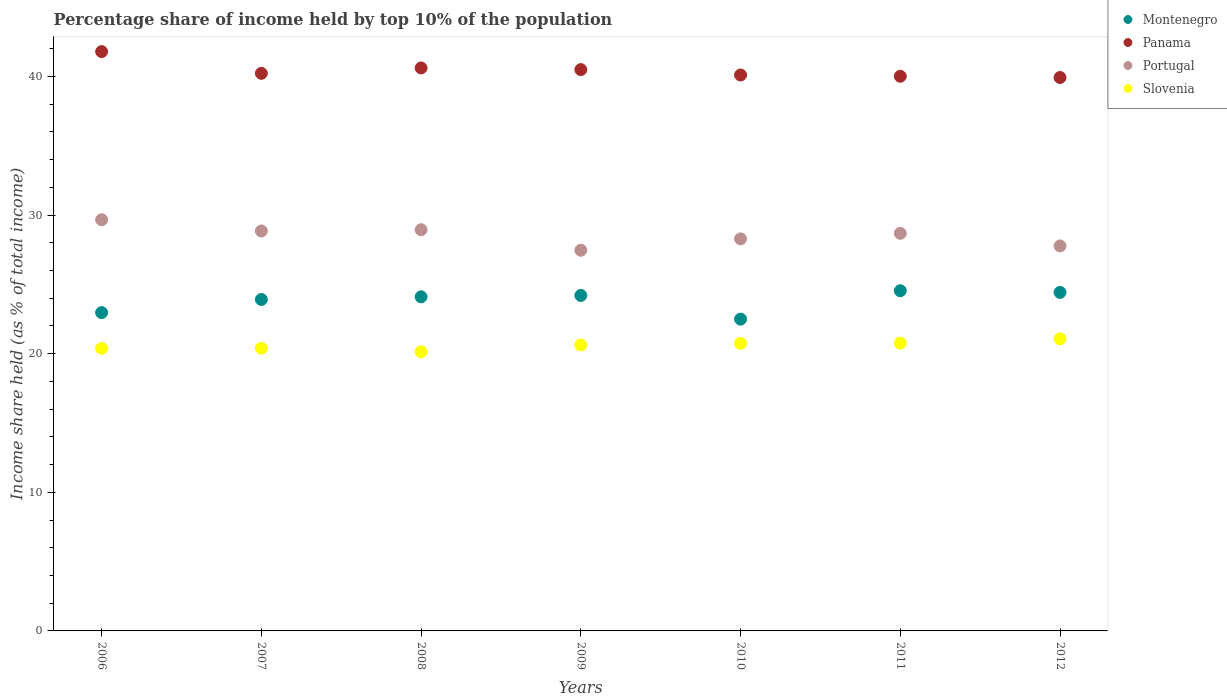Is the number of dotlines equal to the number of legend labels?
Keep it short and to the point. Yes. What is the percentage share of income held by top 10% of the population in Panama in 2009?
Your answer should be very brief. 40.49. Across all years, what is the maximum percentage share of income held by top 10% of the population in Slovenia?
Make the answer very short. 21.07. Across all years, what is the minimum percentage share of income held by top 10% of the population in Montenegro?
Offer a terse response. 22.49. What is the total percentage share of income held by top 10% of the population in Slovenia in the graph?
Your answer should be very brief. 144.11. What is the difference between the percentage share of income held by top 10% of the population in Montenegro in 2008 and that in 2010?
Keep it short and to the point. 1.61. What is the difference between the percentage share of income held by top 10% of the population in Portugal in 2006 and the percentage share of income held by top 10% of the population in Panama in 2007?
Provide a succinct answer. -10.56. What is the average percentage share of income held by top 10% of the population in Portugal per year?
Provide a short and direct response. 28.52. In the year 2006, what is the difference between the percentage share of income held by top 10% of the population in Slovenia and percentage share of income held by top 10% of the population in Montenegro?
Give a very brief answer. -2.58. In how many years, is the percentage share of income held by top 10% of the population in Portugal greater than 36 %?
Give a very brief answer. 0. What is the ratio of the percentage share of income held by top 10% of the population in Montenegro in 2006 to that in 2011?
Give a very brief answer. 0.94. What is the difference between the highest and the second highest percentage share of income held by top 10% of the population in Montenegro?
Your answer should be compact. 0.12. What is the difference between the highest and the lowest percentage share of income held by top 10% of the population in Panama?
Keep it short and to the point. 1.87. Is the sum of the percentage share of income held by top 10% of the population in Portugal in 2009 and 2012 greater than the maximum percentage share of income held by top 10% of the population in Montenegro across all years?
Keep it short and to the point. Yes. Is it the case that in every year, the sum of the percentage share of income held by top 10% of the population in Portugal and percentage share of income held by top 10% of the population in Montenegro  is greater than the percentage share of income held by top 10% of the population in Panama?
Provide a succinct answer. Yes. Is the percentage share of income held by top 10% of the population in Slovenia strictly greater than the percentage share of income held by top 10% of the population in Portugal over the years?
Offer a very short reply. No. Is the percentage share of income held by top 10% of the population in Portugal strictly less than the percentage share of income held by top 10% of the population in Slovenia over the years?
Offer a terse response. No. How many dotlines are there?
Provide a short and direct response. 4. How many years are there in the graph?
Give a very brief answer. 7. What is the difference between two consecutive major ticks on the Y-axis?
Provide a succinct answer. 10. Are the values on the major ticks of Y-axis written in scientific E-notation?
Your response must be concise. No. Where does the legend appear in the graph?
Offer a terse response. Top right. How many legend labels are there?
Offer a terse response. 4. What is the title of the graph?
Keep it short and to the point. Percentage share of income held by top 10% of the population. What is the label or title of the Y-axis?
Your answer should be compact. Income share held (as % of total income). What is the Income share held (as % of total income) of Montenegro in 2006?
Provide a succinct answer. 22.96. What is the Income share held (as % of total income) of Panama in 2006?
Keep it short and to the point. 41.79. What is the Income share held (as % of total income) in Portugal in 2006?
Your answer should be compact. 29.66. What is the Income share held (as % of total income) in Slovenia in 2006?
Provide a succinct answer. 20.38. What is the Income share held (as % of total income) of Montenegro in 2007?
Provide a succinct answer. 23.91. What is the Income share held (as % of total income) in Panama in 2007?
Your response must be concise. 40.22. What is the Income share held (as % of total income) of Portugal in 2007?
Keep it short and to the point. 28.85. What is the Income share held (as % of total income) of Slovenia in 2007?
Provide a short and direct response. 20.39. What is the Income share held (as % of total income) of Montenegro in 2008?
Make the answer very short. 24.1. What is the Income share held (as % of total income) of Panama in 2008?
Your answer should be very brief. 40.61. What is the Income share held (as % of total income) in Portugal in 2008?
Ensure brevity in your answer.  28.94. What is the Income share held (as % of total income) in Slovenia in 2008?
Ensure brevity in your answer.  20.14. What is the Income share held (as % of total income) in Montenegro in 2009?
Offer a terse response. 24.2. What is the Income share held (as % of total income) of Panama in 2009?
Ensure brevity in your answer.  40.49. What is the Income share held (as % of total income) in Portugal in 2009?
Your response must be concise. 27.46. What is the Income share held (as % of total income) in Slovenia in 2009?
Provide a short and direct response. 20.63. What is the Income share held (as % of total income) of Montenegro in 2010?
Offer a very short reply. 22.49. What is the Income share held (as % of total income) in Panama in 2010?
Offer a very short reply. 40.1. What is the Income share held (as % of total income) in Portugal in 2010?
Provide a succinct answer. 28.28. What is the Income share held (as % of total income) of Slovenia in 2010?
Your response must be concise. 20.74. What is the Income share held (as % of total income) of Montenegro in 2011?
Keep it short and to the point. 24.54. What is the Income share held (as % of total income) of Panama in 2011?
Provide a short and direct response. 40.01. What is the Income share held (as % of total income) in Portugal in 2011?
Offer a terse response. 28.68. What is the Income share held (as % of total income) in Slovenia in 2011?
Offer a very short reply. 20.76. What is the Income share held (as % of total income) in Montenegro in 2012?
Provide a short and direct response. 24.42. What is the Income share held (as % of total income) of Panama in 2012?
Give a very brief answer. 39.92. What is the Income share held (as % of total income) in Portugal in 2012?
Your answer should be compact. 27.77. What is the Income share held (as % of total income) of Slovenia in 2012?
Give a very brief answer. 21.07. Across all years, what is the maximum Income share held (as % of total income) of Montenegro?
Give a very brief answer. 24.54. Across all years, what is the maximum Income share held (as % of total income) of Panama?
Offer a terse response. 41.79. Across all years, what is the maximum Income share held (as % of total income) of Portugal?
Make the answer very short. 29.66. Across all years, what is the maximum Income share held (as % of total income) of Slovenia?
Offer a very short reply. 21.07. Across all years, what is the minimum Income share held (as % of total income) in Montenegro?
Your answer should be compact. 22.49. Across all years, what is the minimum Income share held (as % of total income) of Panama?
Provide a short and direct response. 39.92. Across all years, what is the minimum Income share held (as % of total income) in Portugal?
Keep it short and to the point. 27.46. Across all years, what is the minimum Income share held (as % of total income) of Slovenia?
Give a very brief answer. 20.14. What is the total Income share held (as % of total income) in Montenegro in the graph?
Keep it short and to the point. 166.62. What is the total Income share held (as % of total income) of Panama in the graph?
Provide a short and direct response. 283.14. What is the total Income share held (as % of total income) in Portugal in the graph?
Your response must be concise. 199.64. What is the total Income share held (as % of total income) in Slovenia in the graph?
Ensure brevity in your answer.  144.11. What is the difference between the Income share held (as % of total income) of Montenegro in 2006 and that in 2007?
Provide a short and direct response. -0.95. What is the difference between the Income share held (as % of total income) in Panama in 2006 and that in 2007?
Make the answer very short. 1.57. What is the difference between the Income share held (as % of total income) in Portugal in 2006 and that in 2007?
Your answer should be very brief. 0.81. What is the difference between the Income share held (as % of total income) in Slovenia in 2006 and that in 2007?
Keep it short and to the point. -0.01. What is the difference between the Income share held (as % of total income) in Montenegro in 2006 and that in 2008?
Give a very brief answer. -1.14. What is the difference between the Income share held (as % of total income) in Panama in 2006 and that in 2008?
Your answer should be very brief. 1.18. What is the difference between the Income share held (as % of total income) of Portugal in 2006 and that in 2008?
Give a very brief answer. 0.72. What is the difference between the Income share held (as % of total income) in Slovenia in 2006 and that in 2008?
Offer a terse response. 0.24. What is the difference between the Income share held (as % of total income) in Montenegro in 2006 and that in 2009?
Offer a terse response. -1.24. What is the difference between the Income share held (as % of total income) in Slovenia in 2006 and that in 2009?
Provide a short and direct response. -0.25. What is the difference between the Income share held (as % of total income) of Montenegro in 2006 and that in 2010?
Your answer should be compact. 0.47. What is the difference between the Income share held (as % of total income) in Panama in 2006 and that in 2010?
Your answer should be compact. 1.69. What is the difference between the Income share held (as % of total income) in Portugal in 2006 and that in 2010?
Provide a succinct answer. 1.38. What is the difference between the Income share held (as % of total income) in Slovenia in 2006 and that in 2010?
Your answer should be very brief. -0.36. What is the difference between the Income share held (as % of total income) of Montenegro in 2006 and that in 2011?
Make the answer very short. -1.58. What is the difference between the Income share held (as % of total income) of Panama in 2006 and that in 2011?
Give a very brief answer. 1.78. What is the difference between the Income share held (as % of total income) in Portugal in 2006 and that in 2011?
Your answer should be compact. 0.98. What is the difference between the Income share held (as % of total income) in Slovenia in 2006 and that in 2011?
Keep it short and to the point. -0.38. What is the difference between the Income share held (as % of total income) of Montenegro in 2006 and that in 2012?
Your response must be concise. -1.46. What is the difference between the Income share held (as % of total income) of Panama in 2006 and that in 2012?
Keep it short and to the point. 1.87. What is the difference between the Income share held (as % of total income) in Portugal in 2006 and that in 2012?
Your response must be concise. 1.89. What is the difference between the Income share held (as % of total income) of Slovenia in 2006 and that in 2012?
Offer a terse response. -0.69. What is the difference between the Income share held (as % of total income) in Montenegro in 2007 and that in 2008?
Offer a very short reply. -0.19. What is the difference between the Income share held (as % of total income) in Panama in 2007 and that in 2008?
Your answer should be very brief. -0.39. What is the difference between the Income share held (as % of total income) of Portugal in 2007 and that in 2008?
Ensure brevity in your answer.  -0.09. What is the difference between the Income share held (as % of total income) in Montenegro in 2007 and that in 2009?
Keep it short and to the point. -0.29. What is the difference between the Income share held (as % of total income) in Panama in 2007 and that in 2009?
Your answer should be compact. -0.27. What is the difference between the Income share held (as % of total income) in Portugal in 2007 and that in 2009?
Your answer should be compact. 1.39. What is the difference between the Income share held (as % of total income) of Slovenia in 2007 and that in 2009?
Provide a succinct answer. -0.24. What is the difference between the Income share held (as % of total income) in Montenegro in 2007 and that in 2010?
Offer a terse response. 1.42. What is the difference between the Income share held (as % of total income) in Panama in 2007 and that in 2010?
Provide a short and direct response. 0.12. What is the difference between the Income share held (as % of total income) of Portugal in 2007 and that in 2010?
Make the answer very short. 0.57. What is the difference between the Income share held (as % of total income) in Slovenia in 2007 and that in 2010?
Your answer should be compact. -0.35. What is the difference between the Income share held (as % of total income) of Montenegro in 2007 and that in 2011?
Give a very brief answer. -0.63. What is the difference between the Income share held (as % of total income) in Panama in 2007 and that in 2011?
Ensure brevity in your answer.  0.21. What is the difference between the Income share held (as % of total income) in Portugal in 2007 and that in 2011?
Ensure brevity in your answer.  0.17. What is the difference between the Income share held (as % of total income) of Slovenia in 2007 and that in 2011?
Make the answer very short. -0.37. What is the difference between the Income share held (as % of total income) in Montenegro in 2007 and that in 2012?
Provide a short and direct response. -0.51. What is the difference between the Income share held (as % of total income) of Panama in 2007 and that in 2012?
Keep it short and to the point. 0.3. What is the difference between the Income share held (as % of total income) of Portugal in 2007 and that in 2012?
Your answer should be very brief. 1.08. What is the difference between the Income share held (as % of total income) in Slovenia in 2007 and that in 2012?
Your response must be concise. -0.68. What is the difference between the Income share held (as % of total income) in Montenegro in 2008 and that in 2009?
Your answer should be compact. -0.1. What is the difference between the Income share held (as % of total income) in Panama in 2008 and that in 2009?
Your answer should be very brief. 0.12. What is the difference between the Income share held (as % of total income) of Portugal in 2008 and that in 2009?
Provide a succinct answer. 1.48. What is the difference between the Income share held (as % of total income) in Slovenia in 2008 and that in 2009?
Ensure brevity in your answer.  -0.49. What is the difference between the Income share held (as % of total income) in Montenegro in 2008 and that in 2010?
Your answer should be compact. 1.61. What is the difference between the Income share held (as % of total income) in Panama in 2008 and that in 2010?
Provide a short and direct response. 0.51. What is the difference between the Income share held (as % of total income) in Portugal in 2008 and that in 2010?
Offer a terse response. 0.66. What is the difference between the Income share held (as % of total income) in Montenegro in 2008 and that in 2011?
Your answer should be very brief. -0.44. What is the difference between the Income share held (as % of total income) in Portugal in 2008 and that in 2011?
Ensure brevity in your answer.  0.26. What is the difference between the Income share held (as % of total income) in Slovenia in 2008 and that in 2011?
Provide a short and direct response. -0.62. What is the difference between the Income share held (as % of total income) of Montenegro in 2008 and that in 2012?
Your answer should be compact. -0.32. What is the difference between the Income share held (as % of total income) of Panama in 2008 and that in 2012?
Ensure brevity in your answer.  0.69. What is the difference between the Income share held (as % of total income) of Portugal in 2008 and that in 2012?
Give a very brief answer. 1.17. What is the difference between the Income share held (as % of total income) of Slovenia in 2008 and that in 2012?
Your response must be concise. -0.93. What is the difference between the Income share held (as % of total income) in Montenegro in 2009 and that in 2010?
Provide a short and direct response. 1.71. What is the difference between the Income share held (as % of total income) of Panama in 2009 and that in 2010?
Your answer should be compact. 0.39. What is the difference between the Income share held (as % of total income) of Portugal in 2009 and that in 2010?
Provide a succinct answer. -0.82. What is the difference between the Income share held (as % of total income) of Slovenia in 2009 and that in 2010?
Ensure brevity in your answer.  -0.11. What is the difference between the Income share held (as % of total income) of Montenegro in 2009 and that in 2011?
Your response must be concise. -0.34. What is the difference between the Income share held (as % of total income) in Panama in 2009 and that in 2011?
Ensure brevity in your answer.  0.48. What is the difference between the Income share held (as % of total income) in Portugal in 2009 and that in 2011?
Give a very brief answer. -1.22. What is the difference between the Income share held (as % of total income) of Slovenia in 2009 and that in 2011?
Your response must be concise. -0.13. What is the difference between the Income share held (as % of total income) of Montenegro in 2009 and that in 2012?
Offer a terse response. -0.22. What is the difference between the Income share held (as % of total income) of Panama in 2009 and that in 2012?
Keep it short and to the point. 0.57. What is the difference between the Income share held (as % of total income) of Portugal in 2009 and that in 2012?
Give a very brief answer. -0.31. What is the difference between the Income share held (as % of total income) of Slovenia in 2009 and that in 2012?
Your response must be concise. -0.44. What is the difference between the Income share held (as % of total income) of Montenegro in 2010 and that in 2011?
Your answer should be compact. -2.05. What is the difference between the Income share held (as % of total income) of Panama in 2010 and that in 2011?
Give a very brief answer. 0.09. What is the difference between the Income share held (as % of total income) of Portugal in 2010 and that in 2011?
Your answer should be very brief. -0.4. What is the difference between the Income share held (as % of total income) of Slovenia in 2010 and that in 2011?
Provide a succinct answer. -0.02. What is the difference between the Income share held (as % of total income) in Montenegro in 2010 and that in 2012?
Your response must be concise. -1.93. What is the difference between the Income share held (as % of total income) of Panama in 2010 and that in 2012?
Provide a short and direct response. 0.18. What is the difference between the Income share held (as % of total income) of Portugal in 2010 and that in 2012?
Provide a succinct answer. 0.51. What is the difference between the Income share held (as % of total income) in Slovenia in 2010 and that in 2012?
Offer a terse response. -0.33. What is the difference between the Income share held (as % of total income) in Montenegro in 2011 and that in 2012?
Keep it short and to the point. 0.12. What is the difference between the Income share held (as % of total income) in Panama in 2011 and that in 2012?
Ensure brevity in your answer.  0.09. What is the difference between the Income share held (as % of total income) of Portugal in 2011 and that in 2012?
Offer a very short reply. 0.91. What is the difference between the Income share held (as % of total income) in Slovenia in 2011 and that in 2012?
Offer a very short reply. -0.31. What is the difference between the Income share held (as % of total income) in Montenegro in 2006 and the Income share held (as % of total income) in Panama in 2007?
Make the answer very short. -17.26. What is the difference between the Income share held (as % of total income) in Montenegro in 2006 and the Income share held (as % of total income) in Portugal in 2007?
Offer a terse response. -5.89. What is the difference between the Income share held (as % of total income) of Montenegro in 2006 and the Income share held (as % of total income) of Slovenia in 2007?
Your answer should be very brief. 2.57. What is the difference between the Income share held (as % of total income) in Panama in 2006 and the Income share held (as % of total income) in Portugal in 2007?
Provide a succinct answer. 12.94. What is the difference between the Income share held (as % of total income) of Panama in 2006 and the Income share held (as % of total income) of Slovenia in 2007?
Make the answer very short. 21.4. What is the difference between the Income share held (as % of total income) of Portugal in 2006 and the Income share held (as % of total income) of Slovenia in 2007?
Your response must be concise. 9.27. What is the difference between the Income share held (as % of total income) of Montenegro in 2006 and the Income share held (as % of total income) of Panama in 2008?
Provide a succinct answer. -17.65. What is the difference between the Income share held (as % of total income) in Montenegro in 2006 and the Income share held (as % of total income) in Portugal in 2008?
Ensure brevity in your answer.  -5.98. What is the difference between the Income share held (as % of total income) in Montenegro in 2006 and the Income share held (as % of total income) in Slovenia in 2008?
Your answer should be compact. 2.82. What is the difference between the Income share held (as % of total income) of Panama in 2006 and the Income share held (as % of total income) of Portugal in 2008?
Provide a succinct answer. 12.85. What is the difference between the Income share held (as % of total income) of Panama in 2006 and the Income share held (as % of total income) of Slovenia in 2008?
Your answer should be compact. 21.65. What is the difference between the Income share held (as % of total income) in Portugal in 2006 and the Income share held (as % of total income) in Slovenia in 2008?
Provide a succinct answer. 9.52. What is the difference between the Income share held (as % of total income) in Montenegro in 2006 and the Income share held (as % of total income) in Panama in 2009?
Keep it short and to the point. -17.53. What is the difference between the Income share held (as % of total income) in Montenegro in 2006 and the Income share held (as % of total income) in Portugal in 2009?
Provide a succinct answer. -4.5. What is the difference between the Income share held (as % of total income) of Montenegro in 2006 and the Income share held (as % of total income) of Slovenia in 2009?
Provide a short and direct response. 2.33. What is the difference between the Income share held (as % of total income) of Panama in 2006 and the Income share held (as % of total income) of Portugal in 2009?
Give a very brief answer. 14.33. What is the difference between the Income share held (as % of total income) of Panama in 2006 and the Income share held (as % of total income) of Slovenia in 2009?
Your answer should be very brief. 21.16. What is the difference between the Income share held (as % of total income) of Portugal in 2006 and the Income share held (as % of total income) of Slovenia in 2009?
Your answer should be compact. 9.03. What is the difference between the Income share held (as % of total income) of Montenegro in 2006 and the Income share held (as % of total income) of Panama in 2010?
Offer a terse response. -17.14. What is the difference between the Income share held (as % of total income) in Montenegro in 2006 and the Income share held (as % of total income) in Portugal in 2010?
Give a very brief answer. -5.32. What is the difference between the Income share held (as % of total income) in Montenegro in 2006 and the Income share held (as % of total income) in Slovenia in 2010?
Provide a short and direct response. 2.22. What is the difference between the Income share held (as % of total income) of Panama in 2006 and the Income share held (as % of total income) of Portugal in 2010?
Provide a short and direct response. 13.51. What is the difference between the Income share held (as % of total income) of Panama in 2006 and the Income share held (as % of total income) of Slovenia in 2010?
Keep it short and to the point. 21.05. What is the difference between the Income share held (as % of total income) in Portugal in 2006 and the Income share held (as % of total income) in Slovenia in 2010?
Keep it short and to the point. 8.92. What is the difference between the Income share held (as % of total income) in Montenegro in 2006 and the Income share held (as % of total income) in Panama in 2011?
Your response must be concise. -17.05. What is the difference between the Income share held (as % of total income) in Montenegro in 2006 and the Income share held (as % of total income) in Portugal in 2011?
Provide a short and direct response. -5.72. What is the difference between the Income share held (as % of total income) of Panama in 2006 and the Income share held (as % of total income) of Portugal in 2011?
Ensure brevity in your answer.  13.11. What is the difference between the Income share held (as % of total income) in Panama in 2006 and the Income share held (as % of total income) in Slovenia in 2011?
Offer a terse response. 21.03. What is the difference between the Income share held (as % of total income) of Montenegro in 2006 and the Income share held (as % of total income) of Panama in 2012?
Offer a terse response. -16.96. What is the difference between the Income share held (as % of total income) in Montenegro in 2006 and the Income share held (as % of total income) in Portugal in 2012?
Ensure brevity in your answer.  -4.81. What is the difference between the Income share held (as % of total income) of Montenegro in 2006 and the Income share held (as % of total income) of Slovenia in 2012?
Provide a succinct answer. 1.89. What is the difference between the Income share held (as % of total income) in Panama in 2006 and the Income share held (as % of total income) in Portugal in 2012?
Your answer should be very brief. 14.02. What is the difference between the Income share held (as % of total income) in Panama in 2006 and the Income share held (as % of total income) in Slovenia in 2012?
Provide a succinct answer. 20.72. What is the difference between the Income share held (as % of total income) in Portugal in 2006 and the Income share held (as % of total income) in Slovenia in 2012?
Keep it short and to the point. 8.59. What is the difference between the Income share held (as % of total income) in Montenegro in 2007 and the Income share held (as % of total income) in Panama in 2008?
Provide a short and direct response. -16.7. What is the difference between the Income share held (as % of total income) in Montenegro in 2007 and the Income share held (as % of total income) in Portugal in 2008?
Your response must be concise. -5.03. What is the difference between the Income share held (as % of total income) in Montenegro in 2007 and the Income share held (as % of total income) in Slovenia in 2008?
Your answer should be very brief. 3.77. What is the difference between the Income share held (as % of total income) of Panama in 2007 and the Income share held (as % of total income) of Portugal in 2008?
Provide a succinct answer. 11.28. What is the difference between the Income share held (as % of total income) in Panama in 2007 and the Income share held (as % of total income) in Slovenia in 2008?
Offer a very short reply. 20.08. What is the difference between the Income share held (as % of total income) of Portugal in 2007 and the Income share held (as % of total income) of Slovenia in 2008?
Give a very brief answer. 8.71. What is the difference between the Income share held (as % of total income) in Montenegro in 2007 and the Income share held (as % of total income) in Panama in 2009?
Ensure brevity in your answer.  -16.58. What is the difference between the Income share held (as % of total income) in Montenegro in 2007 and the Income share held (as % of total income) in Portugal in 2009?
Provide a short and direct response. -3.55. What is the difference between the Income share held (as % of total income) in Montenegro in 2007 and the Income share held (as % of total income) in Slovenia in 2009?
Your response must be concise. 3.28. What is the difference between the Income share held (as % of total income) of Panama in 2007 and the Income share held (as % of total income) of Portugal in 2009?
Provide a succinct answer. 12.76. What is the difference between the Income share held (as % of total income) of Panama in 2007 and the Income share held (as % of total income) of Slovenia in 2009?
Your response must be concise. 19.59. What is the difference between the Income share held (as % of total income) of Portugal in 2007 and the Income share held (as % of total income) of Slovenia in 2009?
Provide a succinct answer. 8.22. What is the difference between the Income share held (as % of total income) in Montenegro in 2007 and the Income share held (as % of total income) in Panama in 2010?
Your answer should be very brief. -16.19. What is the difference between the Income share held (as % of total income) of Montenegro in 2007 and the Income share held (as % of total income) of Portugal in 2010?
Your answer should be very brief. -4.37. What is the difference between the Income share held (as % of total income) of Montenegro in 2007 and the Income share held (as % of total income) of Slovenia in 2010?
Offer a very short reply. 3.17. What is the difference between the Income share held (as % of total income) in Panama in 2007 and the Income share held (as % of total income) in Portugal in 2010?
Provide a succinct answer. 11.94. What is the difference between the Income share held (as % of total income) of Panama in 2007 and the Income share held (as % of total income) of Slovenia in 2010?
Your answer should be very brief. 19.48. What is the difference between the Income share held (as % of total income) in Portugal in 2007 and the Income share held (as % of total income) in Slovenia in 2010?
Offer a very short reply. 8.11. What is the difference between the Income share held (as % of total income) in Montenegro in 2007 and the Income share held (as % of total income) in Panama in 2011?
Ensure brevity in your answer.  -16.1. What is the difference between the Income share held (as % of total income) of Montenegro in 2007 and the Income share held (as % of total income) of Portugal in 2011?
Ensure brevity in your answer.  -4.77. What is the difference between the Income share held (as % of total income) in Montenegro in 2007 and the Income share held (as % of total income) in Slovenia in 2011?
Your answer should be compact. 3.15. What is the difference between the Income share held (as % of total income) in Panama in 2007 and the Income share held (as % of total income) in Portugal in 2011?
Provide a succinct answer. 11.54. What is the difference between the Income share held (as % of total income) of Panama in 2007 and the Income share held (as % of total income) of Slovenia in 2011?
Offer a terse response. 19.46. What is the difference between the Income share held (as % of total income) of Portugal in 2007 and the Income share held (as % of total income) of Slovenia in 2011?
Give a very brief answer. 8.09. What is the difference between the Income share held (as % of total income) of Montenegro in 2007 and the Income share held (as % of total income) of Panama in 2012?
Your answer should be very brief. -16.01. What is the difference between the Income share held (as % of total income) of Montenegro in 2007 and the Income share held (as % of total income) of Portugal in 2012?
Ensure brevity in your answer.  -3.86. What is the difference between the Income share held (as % of total income) in Montenegro in 2007 and the Income share held (as % of total income) in Slovenia in 2012?
Give a very brief answer. 2.84. What is the difference between the Income share held (as % of total income) in Panama in 2007 and the Income share held (as % of total income) in Portugal in 2012?
Offer a very short reply. 12.45. What is the difference between the Income share held (as % of total income) in Panama in 2007 and the Income share held (as % of total income) in Slovenia in 2012?
Provide a short and direct response. 19.15. What is the difference between the Income share held (as % of total income) of Portugal in 2007 and the Income share held (as % of total income) of Slovenia in 2012?
Keep it short and to the point. 7.78. What is the difference between the Income share held (as % of total income) in Montenegro in 2008 and the Income share held (as % of total income) in Panama in 2009?
Offer a very short reply. -16.39. What is the difference between the Income share held (as % of total income) in Montenegro in 2008 and the Income share held (as % of total income) in Portugal in 2009?
Provide a short and direct response. -3.36. What is the difference between the Income share held (as % of total income) of Montenegro in 2008 and the Income share held (as % of total income) of Slovenia in 2009?
Your answer should be compact. 3.47. What is the difference between the Income share held (as % of total income) of Panama in 2008 and the Income share held (as % of total income) of Portugal in 2009?
Offer a very short reply. 13.15. What is the difference between the Income share held (as % of total income) of Panama in 2008 and the Income share held (as % of total income) of Slovenia in 2009?
Provide a short and direct response. 19.98. What is the difference between the Income share held (as % of total income) in Portugal in 2008 and the Income share held (as % of total income) in Slovenia in 2009?
Provide a short and direct response. 8.31. What is the difference between the Income share held (as % of total income) of Montenegro in 2008 and the Income share held (as % of total income) of Panama in 2010?
Provide a succinct answer. -16. What is the difference between the Income share held (as % of total income) of Montenegro in 2008 and the Income share held (as % of total income) of Portugal in 2010?
Keep it short and to the point. -4.18. What is the difference between the Income share held (as % of total income) in Montenegro in 2008 and the Income share held (as % of total income) in Slovenia in 2010?
Offer a terse response. 3.36. What is the difference between the Income share held (as % of total income) in Panama in 2008 and the Income share held (as % of total income) in Portugal in 2010?
Ensure brevity in your answer.  12.33. What is the difference between the Income share held (as % of total income) of Panama in 2008 and the Income share held (as % of total income) of Slovenia in 2010?
Make the answer very short. 19.87. What is the difference between the Income share held (as % of total income) of Portugal in 2008 and the Income share held (as % of total income) of Slovenia in 2010?
Provide a short and direct response. 8.2. What is the difference between the Income share held (as % of total income) of Montenegro in 2008 and the Income share held (as % of total income) of Panama in 2011?
Keep it short and to the point. -15.91. What is the difference between the Income share held (as % of total income) of Montenegro in 2008 and the Income share held (as % of total income) of Portugal in 2011?
Your answer should be compact. -4.58. What is the difference between the Income share held (as % of total income) of Montenegro in 2008 and the Income share held (as % of total income) of Slovenia in 2011?
Provide a short and direct response. 3.34. What is the difference between the Income share held (as % of total income) of Panama in 2008 and the Income share held (as % of total income) of Portugal in 2011?
Keep it short and to the point. 11.93. What is the difference between the Income share held (as % of total income) in Panama in 2008 and the Income share held (as % of total income) in Slovenia in 2011?
Your response must be concise. 19.85. What is the difference between the Income share held (as % of total income) of Portugal in 2008 and the Income share held (as % of total income) of Slovenia in 2011?
Keep it short and to the point. 8.18. What is the difference between the Income share held (as % of total income) in Montenegro in 2008 and the Income share held (as % of total income) in Panama in 2012?
Your answer should be compact. -15.82. What is the difference between the Income share held (as % of total income) of Montenegro in 2008 and the Income share held (as % of total income) of Portugal in 2012?
Your answer should be very brief. -3.67. What is the difference between the Income share held (as % of total income) of Montenegro in 2008 and the Income share held (as % of total income) of Slovenia in 2012?
Your response must be concise. 3.03. What is the difference between the Income share held (as % of total income) of Panama in 2008 and the Income share held (as % of total income) of Portugal in 2012?
Your answer should be compact. 12.84. What is the difference between the Income share held (as % of total income) in Panama in 2008 and the Income share held (as % of total income) in Slovenia in 2012?
Your response must be concise. 19.54. What is the difference between the Income share held (as % of total income) in Portugal in 2008 and the Income share held (as % of total income) in Slovenia in 2012?
Offer a terse response. 7.87. What is the difference between the Income share held (as % of total income) of Montenegro in 2009 and the Income share held (as % of total income) of Panama in 2010?
Make the answer very short. -15.9. What is the difference between the Income share held (as % of total income) in Montenegro in 2009 and the Income share held (as % of total income) in Portugal in 2010?
Your answer should be compact. -4.08. What is the difference between the Income share held (as % of total income) in Montenegro in 2009 and the Income share held (as % of total income) in Slovenia in 2010?
Offer a very short reply. 3.46. What is the difference between the Income share held (as % of total income) of Panama in 2009 and the Income share held (as % of total income) of Portugal in 2010?
Make the answer very short. 12.21. What is the difference between the Income share held (as % of total income) of Panama in 2009 and the Income share held (as % of total income) of Slovenia in 2010?
Offer a terse response. 19.75. What is the difference between the Income share held (as % of total income) in Portugal in 2009 and the Income share held (as % of total income) in Slovenia in 2010?
Give a very brief answer. 6.72. What is the difference between the Income share held (as % of total income) in Montenegro in 2009 and the Income share held (as % of total income) in Panama in 2011?
Your answer should be very brief. -15.81. What is the difference between the Income share held (as % of total income) of Montenegro in 2009 and the Income share held (as % of total income) of Portugal in 2011?
Make the answer very short. -4.48. What is the difference between the Income share held (as % of total income) of Montenegro in 2009 and the Income share held (as % of total income) of Slovenia in 2011?
Ensure brevity in your answer.  3.44. What is the difference between the Income share held (as % of total income) in Panama in 2009 and the Income share held (as % of total income) in Portugal in 2011?
Offer a very short reply. 11.81. What is the difference between the Income share held (as % of total income) in Panama in 2009 and the Income share held (as % of total income) in Slovenia in 2011?
Keep it short and to the point. 19.73. What is the difference between the Income share held (as % of total income) in Portugal in 2009 and the Income share held (as % of total income) in Slovenia in 2011?
Your answer should be very brief. 6.7. What is the difference between the Income share held (as % of total income) of Montenegro in 2009 and the Income share held (as % of total income) of Panama in 2012?
Ensure brevity in your answer.  -15.72. What is the difference between the Income share held (as % of total income) of Montenegro in 2009 and the Income share held (as % of total income) of Portugal in 2012?
Make the answer very short. -3.57. What is the difference between the Income share held (as % of total income) of Montenegro in 2009 and the Income share held (as % of total income) of Slovenia in 2012?
Give a very brief answer. 3.13. What is the difference between the Income share held (as % of total income) in Panama in 2009 and the Income share held (as % of total income) in Portugal in 2012?
Provide a succinct answer. 12.72. What is the difference between the Income share held (as % of total income) in Panama in 2009 and the Income share held (as % of total income) in Slovenia in 2012?
Keep it short and to the point. 19.42. What is the difference between the Income share held (as % of total income) of Portugal in 2009 and the Income share held (as % of total income) of Slovenia in 2012?
Offer a terse response. 6.39. What is the difference between the Income share held (as % of total income) in Montenegro in 2010 and the Income share held (as % of total income) in Panama in 2011?
Give a very brief answer. -17.52. What is the difference between the Income share held (as % of total income) of Montenegro in 2010 and the Income share held (as % of total income) of Portugal in 2011?
Provide a short and direct response. -6.19. What is the difference between the Income share held (as % of total income) in Montenegro in 2010 and the Income share held (as % of total income) in Slovenia in 2011?
Give a very brief answer. 1.73. What is the difference between the Income share held (as % of total income) in Panama in 2010 and the Income share held (as % of total income) in Portugal in 2011?
Give a very brief answer. 11.42. What is the difference between the Income share held (as % of total income) in Panama in 2010 and the Income share held (as % of total income) in Slovenia in 2011?
Your answer should be very brief. 19.34. What is the difference between the Income share held (as % of total income) in Portugal in 2010 and the Income share held (as % of total income) in Slovenia in 2011?
Offer a terse response. 7.52. What is the difference between the Income share held (as % of total income) of Montenegro in 2010 and the Income share held (as % of total income) of Panama in 2012?
Provide a short and direct response. -17.43. What is the difference between the Income share held (as % of total income) in Montenegro in 2010 and the Income share held (as % of total income) in Portugal in 2012?
Make the answer very short. -5.28. What is the difference between the Income share held (as % of total income) of Montenegro in 2010 and the Income share held (as % of total income) of Slovenia in 2012?
Offer a very short reply. 1.42. What is the difference between the Income share held (as % of total income) of Panama in 2010 and the Income share held (as % of total income) of Portugal in 2012?
Offer a very short reply. 12.33. What is the difference between the Income share held (as % of total income) in Panama in 2010 and the Income share held (as % of total income) in Slovenia in 2012?
Your response must be concise. 19.03. What is the difference between the Income share held (as % of total income) in Portugal in 2010 and the Income share held (as % of total income) in Slovenia in 2012?
Offer a terse response. 7.21. What is the difference between the Income share held (as % of total income) of Montenegro in 2011 and the Income share held (as % of total income) of Panama in 2012?
Your answer should be very brief. -15.38. What is the difference between the Income share held (as % of total income) in Montenegro in 2011 and the Income share held (as % of total income) in Portugal in 2012?
Offer a terse response. -3.23. What is the difference between the Income share held (as % of total income) in Montenegro in 2011 and the Income share held (as % of total income) in Slovenia in 2012?
Your answer should be very brief. 3.47. What is the difference between the Income share held (as % of total income) in Panama in 2011 and the Income share held (as % of total income) in Portugal in 2012?
Provide a succinct answer. 12.24. What is the difference between the Income share held (as % of total income) in Panama in 2011 and the Income share held (as % of total income) in Slovenia in 2012?
Provide a short and direct response. 18.94. What is the difference between the Income share held (as % of total income) in Portugal in 2011 and the Income share held (as % of total income) in Slovenia in 2012?
Your answer should be very brief. 7.61. What is the average Income share held (as % of total income) in Montenegro per year?
Give a very brief answer. 23.8. What is the average Income share held (as % of total income) in Panama per year?
Your answer should be compact. 40.45. What is the average Income share held (as % of total income) of Portugal per year?
Provide a short and direct response. 28.52. What is the average Income share held (as % of total income) in Slovenia per year?
Offer a very short reply. 20.59. In the year 2006, what is the difference between the Income share held (as % of total income) of Montenegro and Income share held (as % of total income) of Panama?
Ensure brevity in your answer.  -18.83. In the year 2006, what is the difference between the Income share held (as % of total income) in Montenegro and Income share held (as % of total income) in Slovenia?
Provide a short and direct response. 2.58. In the year 2006, what is the difference between the Income share held (as % of total income) in Panama and Income share held (as % of total income) in Portugal?
Your response must be concise. 12.13. In the year 2006, what is the difference between the Income share held (as % of total income) of Panama and Income share held (as % of total income) of Slovenia?
Your response must be concise. 21.41. In the year 2006, what is the difference between the Income share held (as % of total income) in Portugal and Income share held (as % of total income) in Slovenia?
Your answer should be compact. 9.28. In the year 2007, what is the difference between the Income share held (as % of total income) of Montenegro and Income share held (as % of total income) of Panama?
Provide a succinct answer. -16.31. In the year 2007, what is the difference between the Income share held (as % of total income) in Montenegro and Income share held (as % of total income) in Portugal?
Give a very brief answer. -4.94. In the year 2007, what is the difference between the Income share held (as % of total income) of Montenegro and Income share held (as % of total income) of Slovenia?
Make the answer very short. 3.52. In the year 2007, what is the difference between the Income share held (as % of total income) of Panama and Income share held (as % of total income) of Portugal?
Provide a succinct answer. 11.37. In the year 2007, what is the difference between the Income share held (as % of total income) in Panama and Income share held (as % of total income) in Slovenia?
Your answer should be compact. 19.83. In the year 2007, what is the difference between the Income share held (as % of total income) in Portugal and Income share held (as % of total income) in Slovenia?
Provide a short and direct response. 8.46. In the year 2008, what is the difference between the Income share held (as % of total income) in Montenegro and Income share held (as % of total income) in Panama?
Provide a short and direct response. -16.51. In the year 2008, what is the difference between the Income share held (as % of total income) in Montenegro and Income share held (as % of total income) in Portugal?
Your response must be concise. -4.84. In the year 2008, what is the difference between the Income share held (as % of total income) of Montenegro and Income share held (as % of total income) of Slovenia?
Offer a terse response. 3.96. In the year 2008, what is the difference between the Income share held (as % of total income) in Panama and Income share held (as % of total income) in Portugal?
Offer a terse response. 11.67. In the year 2008, what is the difference between the Income share held (as % of total income) in Panama and Income share held (as % of total income) in Slovenia?
Give a very brief answer. 20.47. In the year 2009, what is the difference between the Income share held (as % of total income) in Montenegro and Income share held (as % of total income) in Panama?
Keep it short and to the point. -16.29. In the year 2009, what is the difference between the Income share held (as % of total income) in Montenegro and Income share held (as % of total income) in Portugal?
Provide a short and direct response. -3.26. In the year 2009, what is the difference between the Income share held (as % of total income) in Montenegro and Income share held (as % of total income) in Slovenia?
Give a very brief answer. 3.57. In the year 2009, what is the difference between the Income share held (as % of total income) in Panama and Income share held (as % of total income) in Portugal?
Ensure brevity in your answer.  13.03. In the year 2009, what is the difference between the Income share held (as % of total income) in Panama and Income share held (as % of total income) in Slovenia?
Provide a short and direct response. 19.86. In the year 2009, what is the difference between the Income share held (as % of total income) in Portugal and Income share held (as % of total income) in Slovenia?
Offer a terse response. 6.83. In the year 2010, what is the difference between the Income share held (as % of total income) of Montenegro and Income share held (as % of total income) of Panama?
Ensure brevity in your answer.  -17.61. In the year 2010, what is the difference between the Income share held (as % of total income) of Montenegro and Income share held (as % of total income) of Portugal?
Provide a succinct answer. -5.79. In the year 2010, what is the difference between the Income share held (as % of total income) in Panama and Income share held (as % of total income) in Portugal?
Provide a short and direct response. 11.82. In the year 2010, what is the difference between the Income share held (as % of total income) in Panama and Income share held (as % of total income) in Slovenia?
Your answer should be very brief. 19.36. In the year 2010, what is the difference between the Income share held (as % of total income) of Portugal and Income share held (as % of total income) of Slovenia?
Ensure brevity in your answer.  7.54. In the year 2011, what is the difference between the Income share held (as % of total income) in Montenegro and Income share held (as % of total income) in Panama?
Give a very brief answer. -15.47. In the year 2011, what is the difference between the Income share held (as % of total income) in Montenegro and Income share held (as % of total income) in Portugal?
Offer a terse response. -4.14. In the year 2011, what is the difference between the Income share held (as % of total income) in Montenegro and Income share held (as % of total income) in Slovenia?
Offer a very short reply. 3.78. In the year 2011, what is the difference between the Income share held (as % of total income) of Panama and Income share held (as % of total income) of Portugal?
Your answer should be compact. 11.33. In the year 2011, what is the difference between the Income share held (as % of total income) of Panama and Income share held (as % of total income) of Slovenia?
Provide a succinct answer. 19.25. In the year 2011, what is the difference between the Income share held (as % of total income) of Portugal and Income share held (as % of total income) of Slovenia?
Your response must be concise. 7.92. In the year 2012, what is the difference between the Income share held (as % of total income) in Montenegro and Income share held (as % of total income) in Panama?
Ensure brevity in your answer.  -15.5. In the year 2012, what is the difference between the Income share held (as % of total income) of Montenegro and Income share held (as % of total income) of Portugal?
Keep it short and to the point. -3.35. In the year 2012, what is the difference between the Income share held (as % of total income) of Montenegro and Income share held (as % of total income) of Slovenia?
Ensure brevity in your answer.  3.35. In the year 2012, what is the difference between the Income share held (as % of total income) of Panama and Income share held (as % of total income) of Portugal?
Make the answer very short. 12.15. In the year 2012, what is the difference between the Income share held (as % of total income) of Panama and Income share held (as % of total income) of Slovenia?
Your answer should be compact. 18.85. In the year 2012, what is the difference between the Income share held (as % of total income) of Portugal and Income share held (as % of total income) of Slovenia?
Your answer should be compact. 6.7. What is the ratio of the Income share held (as % of total income) of Montenegro in 2006 to that in 2007?
Ensure brevity in your answer.  0.96. What is the ratio of the Income share held (as % of total income) in Panama in 2006 to that in 2007?
Keep it short and to the point. 1.04. What is the ratio of the Income share held (as % of total income) in Portugal in 2006 to that in 2007?
Keep it short and to the point. 1.03. What is the ratio of the Income share held (as % of total income) in Slovenia in 2006 to that in 2007?
Offer a very short reply. 1. What is the ratio of the Income share held (as % of total income) of Montenegro in 2006 to that in 2008?
Your answer should be compact. 0.95. What is the ratio of the Income share held (as % of total income) in Panama in 2006 to that in 2008?
Offer a very short reply. 1.03. What is the ratio of the Income share held (as % of total income) of Portugal in 2006 to that in 2008?
Offer a very short reply. 1.02. What is the ratio of the Income share held (as % of total income) of Slovenia in 2006 to that in 2008?
Make the answer very short. 1.01. What is the ratio of the Income share held (as % of total income) in Montenegro in 2006 to that in 2009?
Ensure brevity in your answer.  0.95. What is the ratio of the Income share held (as % of total income) of Panama in 2006 to that in 2009?
Your response must be concise. 1.03. What is the ratio of the Income share held (as % of total income) in Portugal in 2006 to that in 2009?
Your response must be concise. 1.08. What is the ratio of the Income share held (as % of total income) in Slovenia in 2006 to that in 2009?
Offer a terse response. 0.99. What is the ratio of the Income share held (as % of total income) in Montenegro in 2006 to that in 2010?
Your response must be concise. 1.02. What is the ratio of the Income share held (as % of total income) of Panama in 2006 to that in 2010?
Give a very brief answer. 1.04. What is the ratio of the Income share held (as % of total income) in Portugal in 2006 to that in 2010?
Give a very brief answer. 1.05. What is the ratio of the Income share held (as % of total income) in Slovenia in 2006 to that in 2010?
Your answer should be very brief. 0.98. What is the ratio of the Income share held (as % of total income) in Montenegro in 2006 to that in 2011?
Your answer should be compact. 0.94. What is the ratio of the Income share held (as % of total income) of Panama in 2006 to that in 2011?
Offer a terse response. 1.04. What is the ratio of the Income share held (as % of total income) in Portugal in 2006 to that in 2011?
Provide a short and direct response. 1.03. What is the ratio of the Income share held (as % of total income) of Slovenia in 2006 to that in 2011?
Your answer should be very brief. 0.98. What is the ratio of the Income share held (as % of total income) in Montenegro in 2006 to that in 2012?
Ensure brevity in your answer.  0.94. What is the ratio of the Income share held (as % of total income) of Panama in 2006 to that in 2012?
Ensure brevity in your answer.  1.05. What is the ratio of the Income share held (as % of total income) in Portugal in 2006 to that in 2012?
Your answer should be very brief. 1.07. What is the ratio of the Income share held (as % of total income) in Slovenia in 2006 to that in 2012?
Your response must be concise. 0.97. What is the ratio of the Income share held (as % of total income) in Montenegro in 2007 to that in 2008?
Your answer should be very brief. 0.99. What is the ratio of the Income share held (as % of total income) of Slovenia in 2007 to that in 2008?
Provide a short and direct response. 1.01. What is the ratio of the Income share held (as % of total income) of Panama in 2007 to that in 2009?
Your answer should be compact. 0.99. What is the ratio of the Income share held (as % of total income) in Portugal in 2007 to that in 2009?
Your answer should be compact. 1.05. What is the ratio of the Income share held (as % of total income) of Slovenia in 2007 to that in 2009?
Ensure brevity in your answer.  0.99. What is the ratio of the Income share held (as % of total income) of Montenegro in 2007 to that in 2010?
Your response must be concise. 1.06. What is the ratio of the Income share held (as % of total income) in Panama in 2007 to that in 2010?
Give a very brief answer. 1. What is the ratio of the Income share held (as % of total income) of Portugal in 2007 to that in 2010?
Ensure brevity in your answer.  1.02. What is the ratio of the Income share held (as % of total income) in Slovenia in 2007 to that in 2010?
Make the answer very short. 0.98. What is the ratio of the Income share held (as % of total income) in Montenegro in 2007 to that in 2011?
Your answer should be very brief. 0.97. What is the ratio of the Income share held (as % of total income) of Panama in 2007 to that in 2011?
Make the answer very short. 1.01. What is the ratio of the Income share held (as % of total income) in Portugal in 2007 to that in 2011?
Make the answer very short. 1.01. What is the ratio of the Income share held (as % of total income) of Slovenia in 2007 to that in 2011?
Your response must be concise. 0.98. What is the ratio of the Income share held (as % of total income) in Montenegro in 2007 to that in 2012?
Provide a short and direct response. 0.98. What is the ratio of the Income share held (as % of total income) in Panama in 2007 to that in 2012?
Your response must be concise. 1.01. What is the ratio of the Income share held (as % of total income) of Portugal in 2007 to that in 2012?
Give a very brief answer. 1.04. What is the ratio of the Income share held (as % of total income) in Montenegro in 2008 to that in 2009?
Provide a succinct answer. 1. What is the ratio of the Income share held (as % of total income) of Panama in 2008 to that in 2009?
Offer a very short reply. 1. What is the ratio of the Income share held (as % of total income) of Portugal in 2008 to that in 2009?
Keep it short and to the point. 1.05. What is the ratio of the Income share held (as % of total income) in Slovenia in 2008 to that in 2009?
Ensure brevity in your answer.  0.98. What is the ratio of the Income share held (as % of total income) in Montenegro in 2008 to that in 2010?
Ensure brevity in your answer.  1.07. What is the ratio of the Income share held (as % of total income) in Panama in 2008 to that in 2010?
Provide a succinct answer. 1.01. What is the ratio of the Income share held (as % of total income) in Portugal in 2008 to that in 2010?
Provide a succinct answer. 1.02. What is the ratio of the Income share held (as % of total income) of Slovenia in 2008 to that in 2010?
Offer a terse response. 0.97. What is the ratio of the Income share held (as % of total income) in Montenegro in 2008 to that in 2011?
Provide a short and direct response. 0.98. What is the ratio of the Income share held (as % of total income) in Panama in 2008 to that in 2011?
Your response must be concise. 1.01. What is the ratio of the Income share held (as % of total income) in Portugal in 2008 to that in 2011?
Make the answer very short. 1.01. What is the ratio of the Income share held (as % of total income) in Slovenia in 2008 to that in 2011?
Ensure brevity in your answer.  0.97. What is the ratio of the Income share held (as % of total income) of Montenegro in 2008 to that in 2012?
Offer a very short reply. 0.99. What is the ratio of the Income share held (as % of total income) in Panama in 2008 to that in 2012?
Give a very brief answer. 1.02. What is the ratio of the Income share held (as % of total income) of Portugal in 2008 to that in 2012?
Provide a succinct answer. 1.04. What is the ratio of the Income share held (as % of total income) of Slovenia in 2008 to that in 2012?
Ensure brevity in your answer.  0.96. What is the ratio of the Income share held (as % of total income) of Montenegro in 2009 to that in 2010?
Ensure brevity in your answer.  1.08. What is the ratio of the Income share held (as % of total income) of Panama in 2009 to that in 2010?
Your response must be concise. 1.01. What is the ratio of the Income share held (as % of total income) in Montenegro in 2009 to that in 2011?
Your answer should be compact. 0.99. What is the ratio of the Income share held (as % of total income) in Panama in 2009 to that in 2011?
Give a very brief answer. 1.01. What is the ratio of the Income share held (as % of total income) of Portugal in 2009 to that in 2011?
Your answer should be very brief. 0.96. What is the ratio of the Income share held (as % of total income) in Panama in 2009 to that in 2012?
Make the answer very short. 1.01. What is the ratio of the Income share held (as % of total income) of Portugal in 2009 to that in 2012?
Provide a succinct answer. 0.99. What is the ratio of the Income share held (as % of total income) in Slovenia in 2009 to that in 2012?
Provide a succinct answer. 0.98. What is the ratio of the Income share held (as % of total income) of Montenegro in 2010 to that in 2011?
Give a very brief answer. 0.92. What is the ratio of the Income share held (as % of total income) of Portugal in 2010 to that in 2011?
Your answer should be very brief. 0.99. What is the ratio of the Income share held (as % of total income) in Montenegro in 2010 to that in 2012?
Offer a very short reply. 0.92. What is the ratio of the Income share held (as % of total income) in Portugal in 2010 to that in 2012?
Your answer should be compact. 1.02. What is the ratio of the Income share held (as % of total income) of Slovenia in 2010 to that in 2012?
Your answer should be compact. 0.98. What is the ratio of the Income share held (as % of total income) in Montenegro in 2011 to that in 2012?
Your response must be concise. 1. What is the ratio of the Income share held (as % of total income) of Portugal in 2011 to that in 2012?
Ensure brevity in your answer.  1.03. What is the difference between the highest and the second highest Income share held (as % of total income) of Montenegro?
Make the answer very short. 0.12. What is the difference between the highest and the second highest Income share held (as % of total income) of Panama?
Your answer should be compact. 1.18. What is the difference between the highest and the second highest Income share held (as % of total income) in Portugal?
Your response must be concise. 0.72. What is the difference between the highest and the second highest Income share held (as % of total income) of Slovenia?
Provide a short and direct response. 0.31. What is the difference between the highest and the lowest Income share held (as % of total income) of Montenegro?
Your response must be concise. 2.05. What is the difference between the highest and the lowest Income share held (as % of total income) in Panama?
Keep it short and to the point. 1.87. What is the difference between the highest and the lowest Income share held (as % of total income) of Portugal?
Keep it short and to the point. 2.2. What is the difference between the highest and the lowest Income share held (as % of total income) of Slovenia?
Provide a short and direct response. 0.93. 